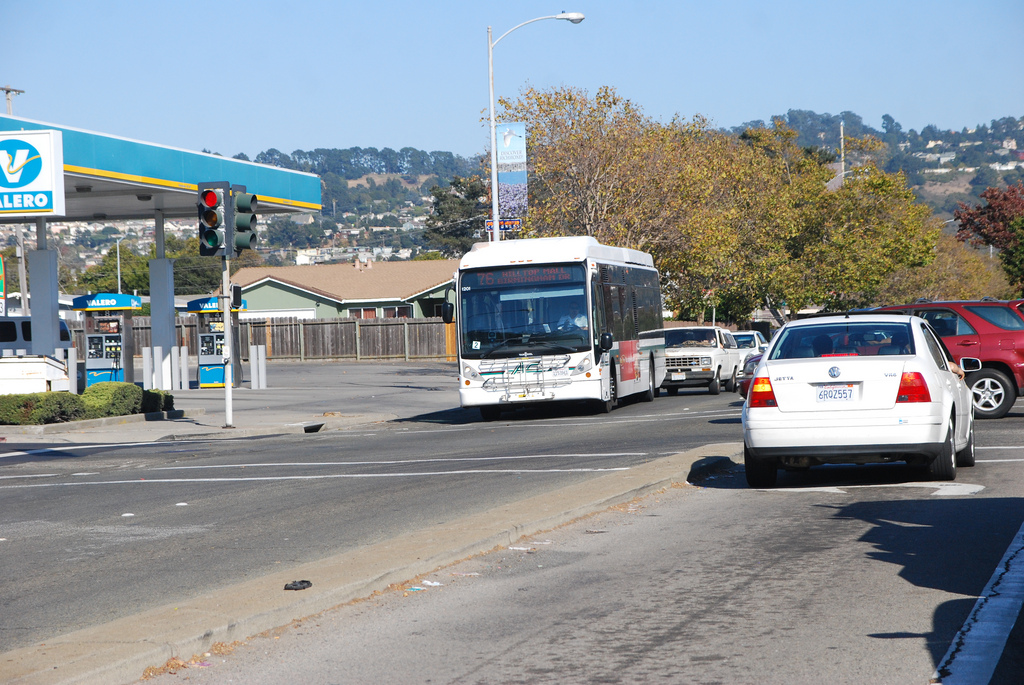Can you tell me what kind of trees are lining the street? The trees lining the street appear to be a mix of deciduous trees, possibly oaks or maples, showing green foliage typical for a sunny daytime. 